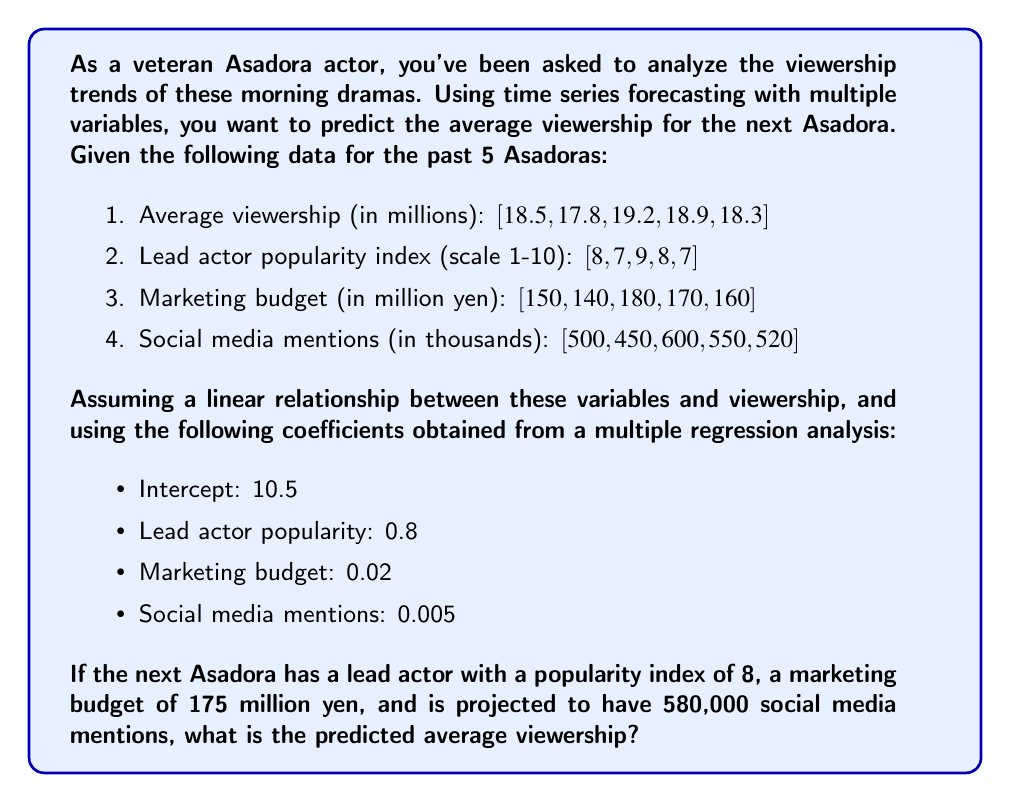Solve this math problem. To solve this problem, we'll use a multiple linear regression model for time series forecasting. The general form of our model is:

$$ Y = \beta_0 + \beta_1X_1 + \beta_2X_2 + \beta_3X_3 + \epsilon $$

Where:
$Y$ is the predicted viewership
$\beta_0$ is the intercept
$\beta_1, \beta_2, \beta_3$ are the coefficients for each variable
$X_1, X_2, X_3$ are the values of each variable
$\epsilon$ is the error term (which we'll ignore for prediction purposes)

Given coefficients:
$\beta_0$ (Intercept) = 10.5
$\beta_1$ (Lead actor popularity) = 0.8
$\beta_2$ (Marketing budget) = 0.02
$\beta_3$ (Social media mentions) = 0.005

For the next Asadora:
$X_1$ (Lead actor popularity) = 8
$X_2$ (Marketing budget) = 175
$X_3$ (Social media mentions) = 580

Let's substitute these values into our equation:

$$ Y = 10.5 + 0.8(8) + 0.02(175) + 0.005(580) $$

Now, let's calculate step by step:

1. $0.8(8) = 6.4$
2. $0.02(175) = 3.5$
3. $0.005(580) = 2.9$

Summing up all components:

$$ Y = 10.5 + 6.4 + 3.5 + 2.9 = 23.3 $$

Therefore, the predicted average viewership for the next Asadora is 23.3 million viewers.
Answer: 23.3 million viewers 